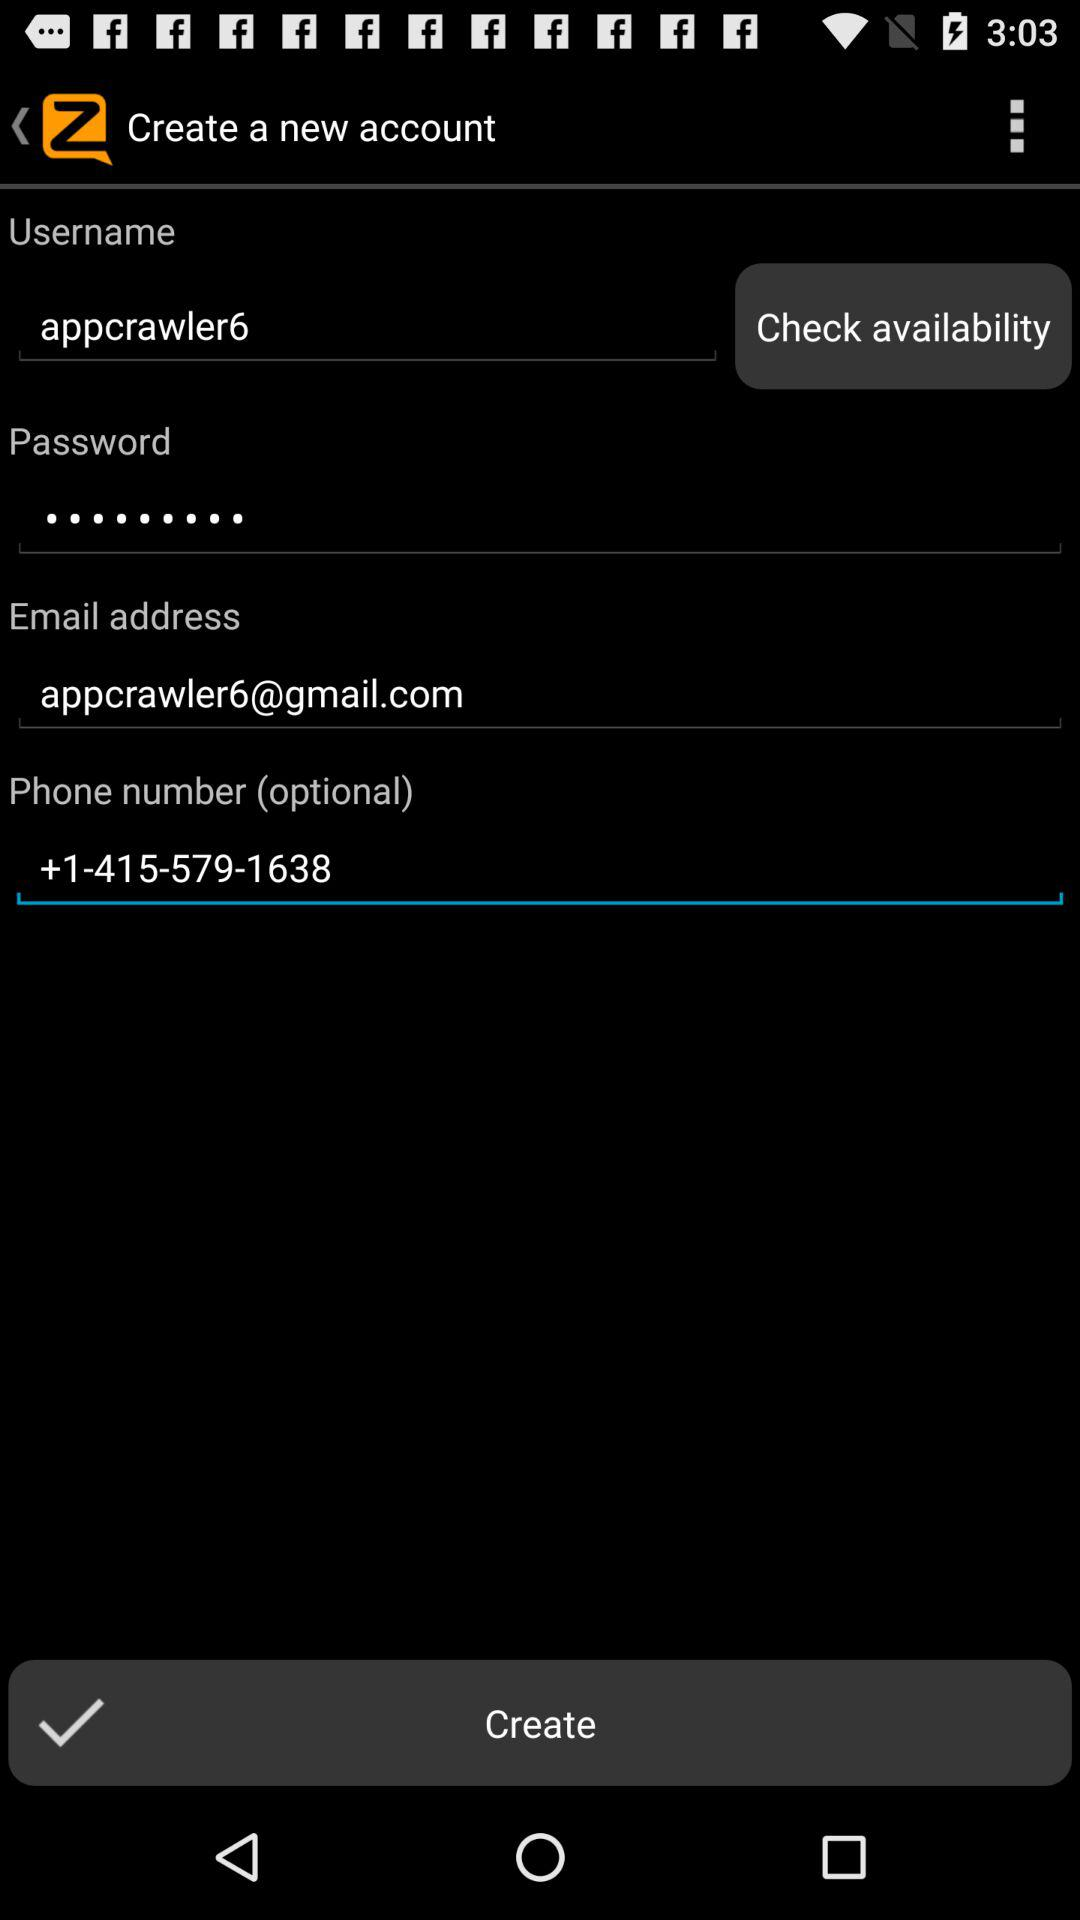What is the username? The username is "appcrawler6". 